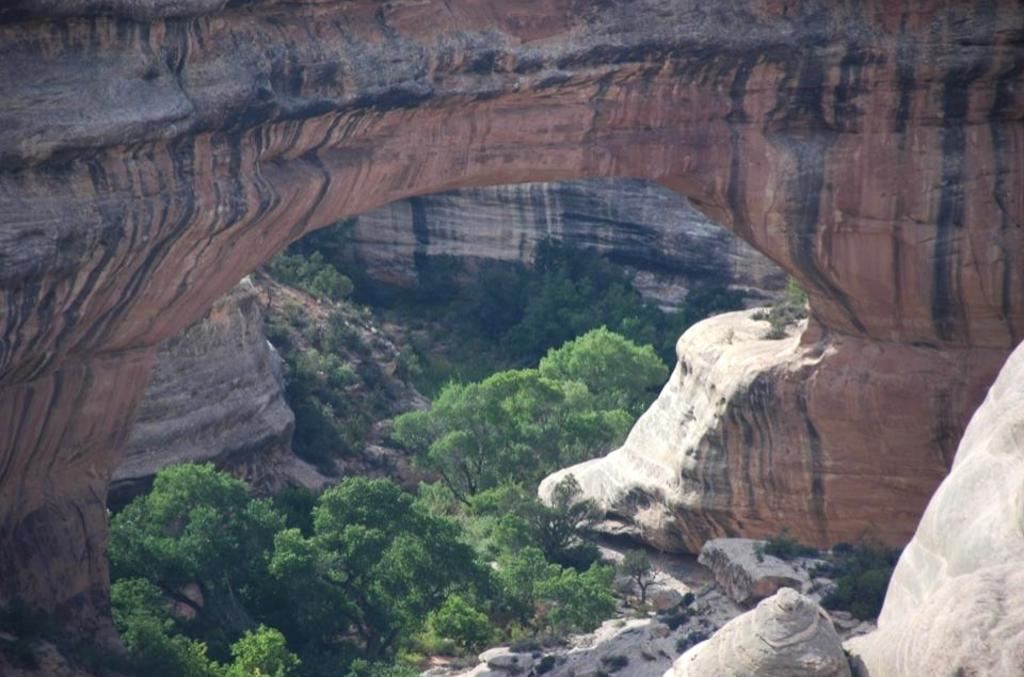What type of vegetation is at the bottom of the image? There are trees at the bottom of the image. What type of natural formations can be seen in the image? There are rocks and mountains in the image. What type of plastic structure can be seen in the image? There is no plastic structure present in the image. Who is the creator of the mountains in the image? The creator of the mountains cannot be determined from the image, as they are natural formations. 